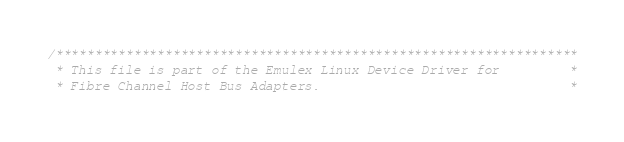Convert code to text. <code><loc_0><loc_0><loc_500><loc_500><_C_>/*******************************************************************
 * This file is part of the Emulex Linux Device Driver for         *
 * Fibre Channel Host Bus Adapters.                                *</code> 